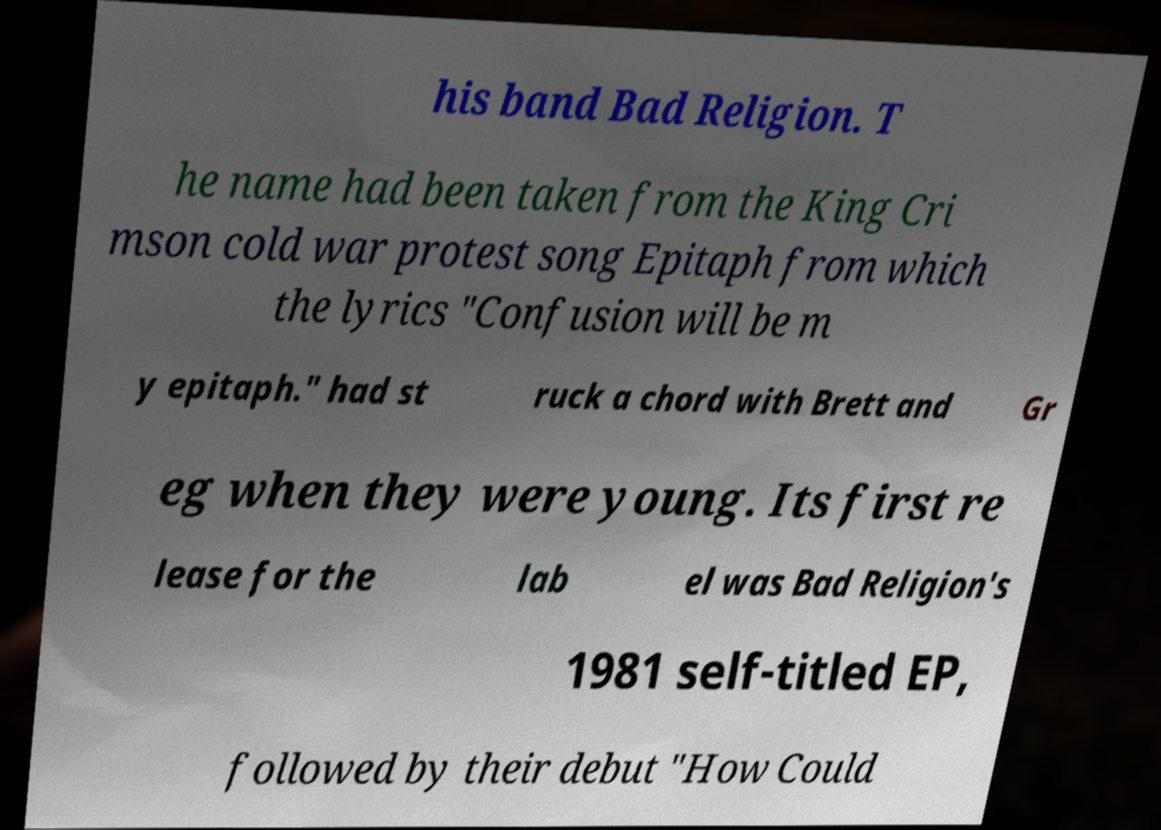For documentation purposes, I need the text within this image transcribed. Could you provide that? his band Bad Religion. T he name had been taken from the King Cri mson cold war protest song Epitaph from which the lyrics "Confusion will be m y epitaph." had st ruck a chord with Brett and Gr eg when they were young. Its first re lease for the lab el was Bad Religion's 1981 self-titled EP, followed by their debut "How Could 